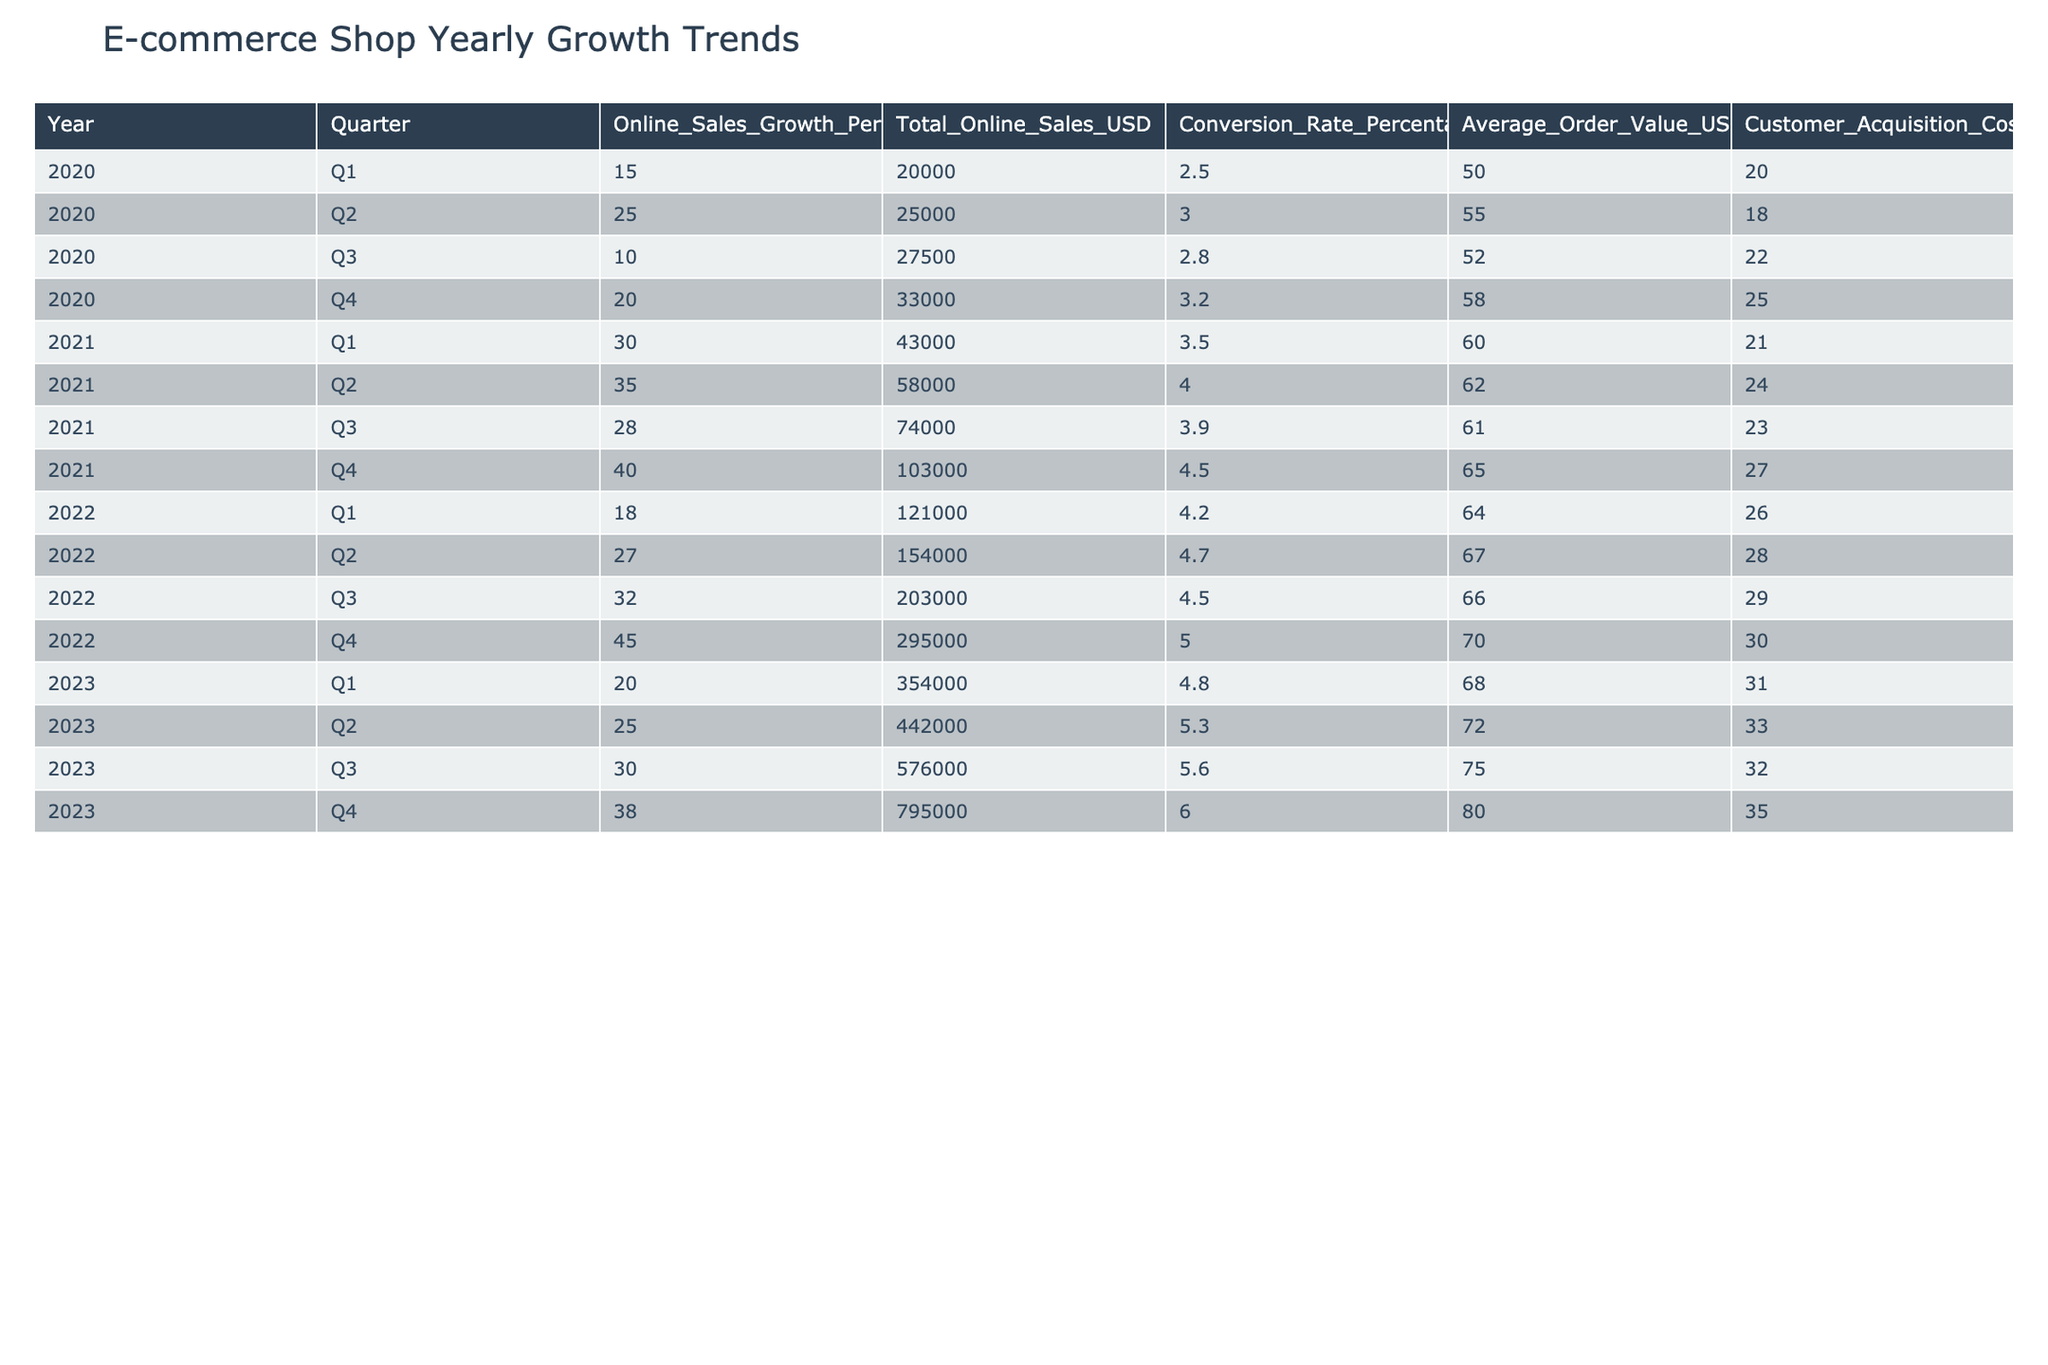What was the total online sales in Q3 of 2022? In the table, locate the row for Q3 of 2022. The total online sales for that quarter is listed as 203000 USD.
Answer: 203000 USD What is the average conversion rate for the year 2023? To find the average conversion rate for 2023, take the values for each quarter: 4.8, 5.3, 5.6, and 6.0. Calculate the average: (4.8 + 5.3 + 5.6 + 6.0) / 4 = 5.425.
Answer: 5.425 Did online sales grow by more than 25 percent in Q4 of 2021? Check the online sales growth percentage for Q4 2021 in the table, which is 40 percent. Since 40 is greater than 25, the answer is yes.
Answer: Yes What is the difference in average order value between Q1 2021 and Q1 2023? Find the average order values for Q1 2021 (60 USD) and Q1 2023 (68 USD). The difference is calculated as 68 - 60 = 8 USD.
Answer: 8 USD What was the total customer acquisition cost for all quarters in 2022? Look at the customer acquisition costs for each quarter in 2022: 26, 28, 29, and 30. Add these values together: 26 + 28 + 29 + 30 = 113.
Answer: 113 USD How does the online sales growth percentage in Q2 2022 compare to Q2 2021? Review the online sales growth percentages: in Q2 2021 it was 35 percent, and in Q2 2022, it was 27 percent. Since 27 is less than 35, the growth percentage decreased.
Answer: Decreased What is the maximum total online sales recorded in the table? Examine the Total Online Sales USD column for the maximum value. The highest total online sales value is 795000 USD, recorded in Q4 of 2023.
Answer: 795000 USD For which quarter in 2020 was the online sales growth percentage the lowest? Identify the online sales growth percentages for all quarters in 2020: 15, 25, 10, and 20. The lowest percentage is 10 percent in Q3 of 2020.
Answer: Q3 2020 What was the cumulative online sales growth percentage from 2020 to 2022? Add the growth percentages from each quarter during these years: 15 + 25 + 10 + 20 + 30 + 35 + 28 + 40 + 18 + 27 + 32 + 45 = 355.
Answer: 355 percent 